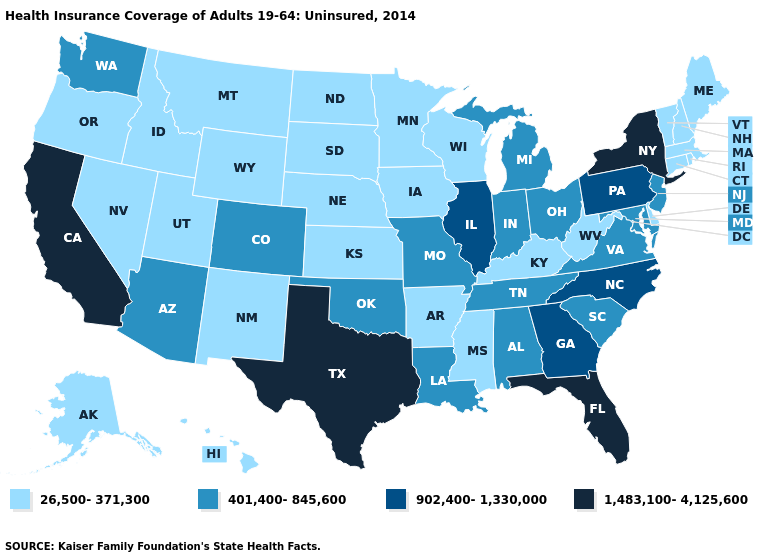What is the highest value in the USA?
Give a very brief answer. 1,483,100-4,125,600. Among the states that border New York , does Pennsylvania have the highest value?
Concise answer only. Yes. Name the states that have a value in the range 1,483,100-4,125,600?
Give a very brief answer. California, Florida, New York, Texas. Does the first symbol in the legend represent the smallest category?
Keep it brief. Yes. What is the lowest value in the USA?
Answer briefly. 26,500-371,300. Does Illinois have the highest value in the MidWest?
Give a very brief answer. Yes. Does Utah have the highest value in the West?
Answer briefly. No. Among the states that border West Virginia , does Kentucky have the lowest value?
Give a very brief answer. Yes. Does Alabama have the same value as Michigan?
Concise answer only. Yes. Does Utah have the lowest value in the West?
Short answer required. Yes. Which states have the lowest value in the West?
Be succinct. Alaska, Hawaii, Idaho, Montana, Nevada, New Mexico, Oregon, Utah, Wyoming. Among the states that border Maryland , which have the highest value?
Short answer required. Pennsylvania. Does Wyoming have the same value as Kentucky?
Concise answer only. Yes. What is the value of Oklahoma?
Answer briefly. 401,400-845,600. What is the value of Tennessee?
Short answer required. 401,400-845,600. 